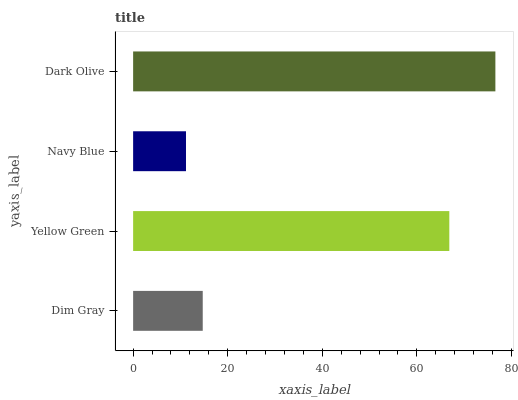Is Navy Blue the minimum?
Answer yes or no. Yes. Is Dark Olive the maximum?
Answer yes or no. Yes. Is Yellow Green the minimum?
Answer yes or no. No. Is Yellow Green the maximum?
Answer yes or no. No. Is Yellow Green greater than Dim Gray?
Answer yes or no. Yes. Is Dim Gray less than Yellow Green?
Answer yes or no. Yes. Is Dim Gray greater than Yellow Green?
Answer yes or no. No. Is Yellow Green less than Dim Gray?
Answer yes or no. No. Is Yellow Green the high median?
Answer yes or no. Yes. Is Dim Gray the low median?
Answer yes or no. Yes. Is Dark Olive the high median?
Answer yes or no. No. Is Yellow Green the low median?
Answer yes or no. No. 